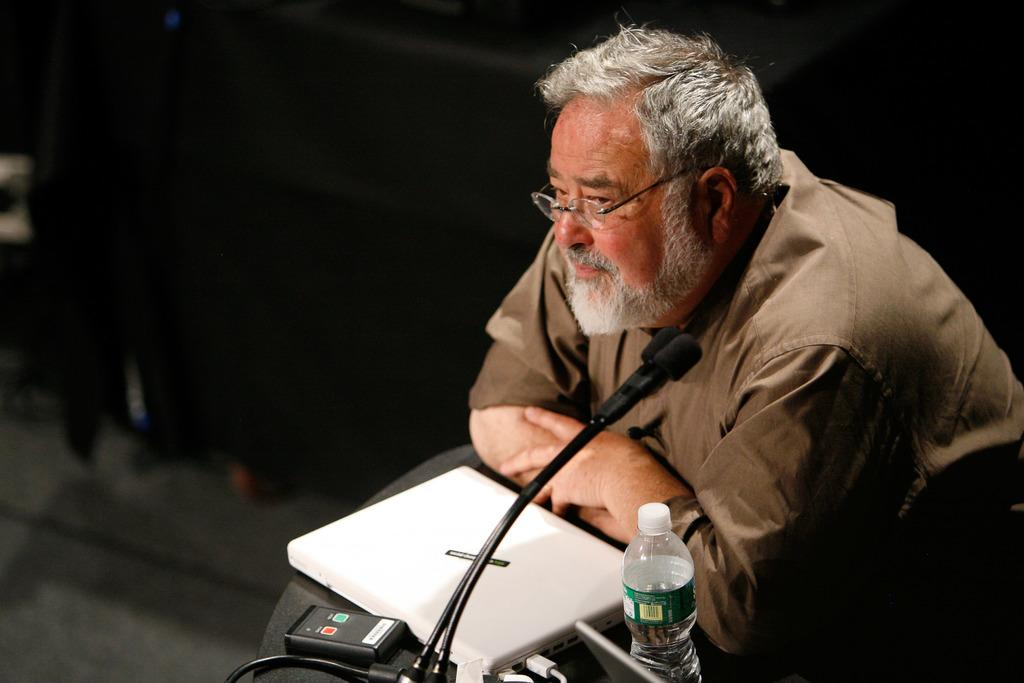Who is the main subject in the image? There is a man in the image. What is the man doing in the image? The man is standing at a podium. What is the man wearing in the image? The man is wearing a brown shirt and spectacles. What objects are on the podium with the man? There is a laptop, a mic, a scanner, and a water bottle on the podium. Are there any other items on the podium? Yes, there are other items on the podium. What type of crow is sitting on the man's shoulder in the image? There is no crow present in the image. What type of sweater is the man wearing in the image? The man is not wearing a sweater in the image; he is wearing a brown shirt. 